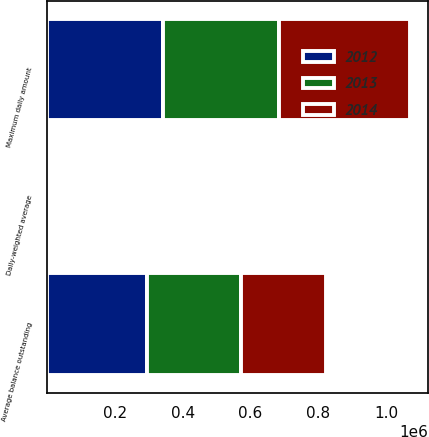<chart> <loc_0><loc_0><loc_500><loc_500><stacked_bar_chart><ecel><fcel>Average balance outstanding<fcel>Daily-weighted average<fcel>Maximum daily amount<nl><fcel>2012<fcel>296246<fcel>0.26<fcel>343000<nl><fcel>2013<fcel>274435<fcel>0.33<fcel>340140<nl><fcel>2014<fcel>250401<fcel>0.48<fcel>385000<nl></chart> 